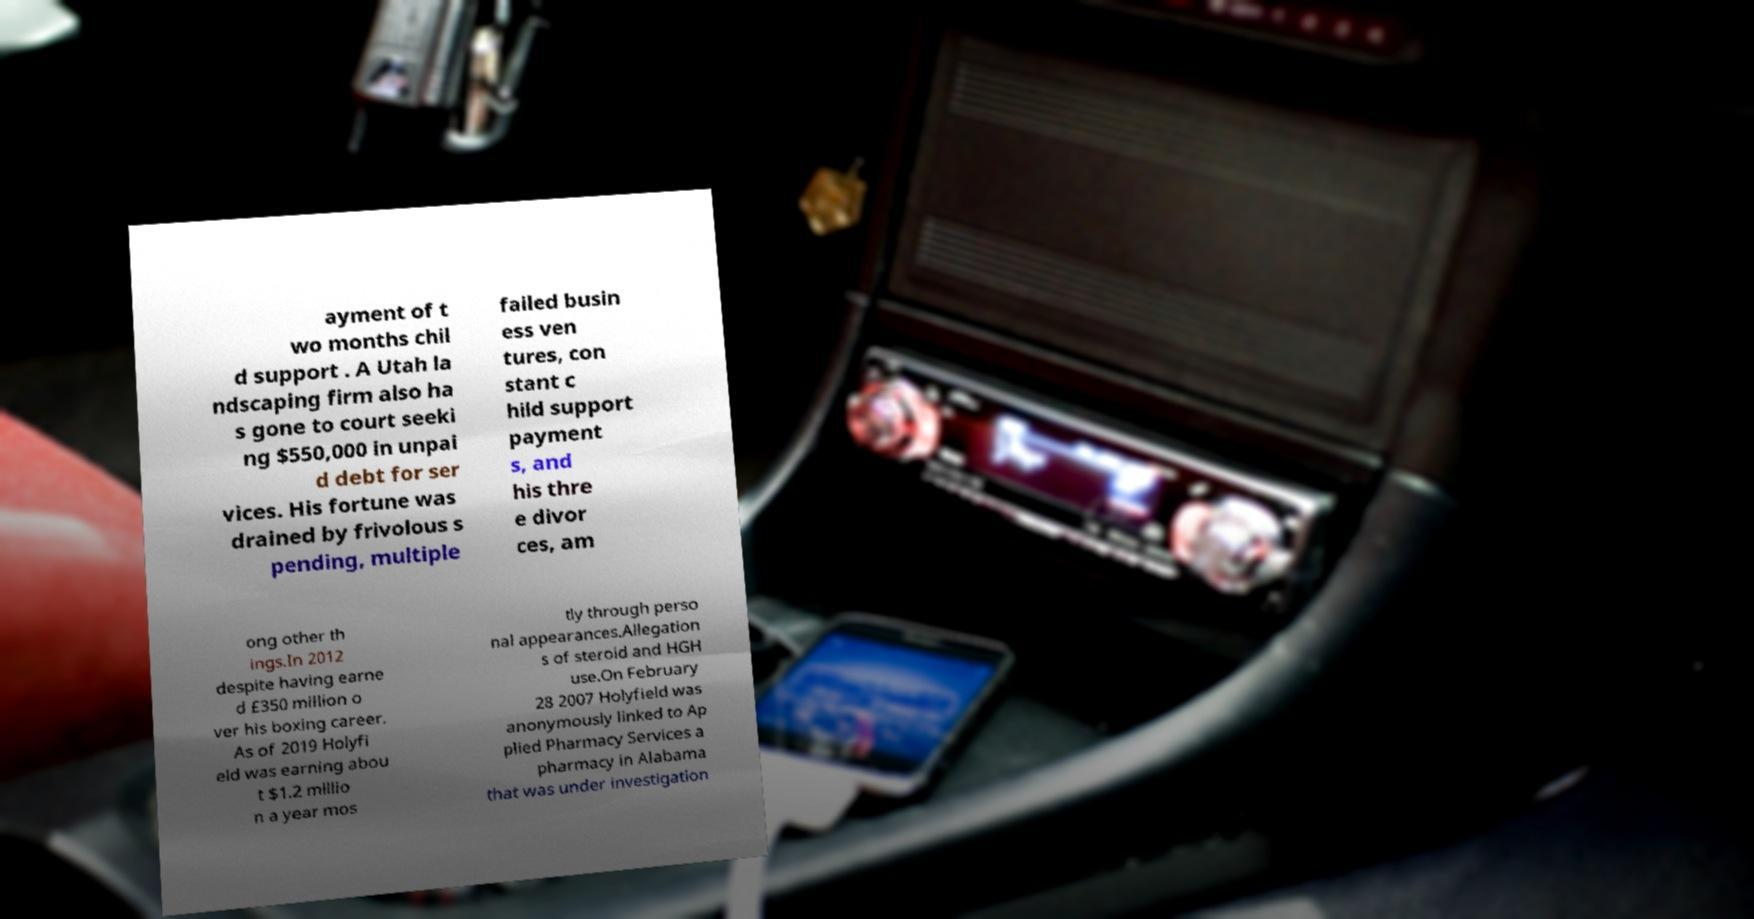Could you assist in decoding the text presented in this image and type it out clearly? ayment of t wo months chil d support . A Utah la ndscaping firm also ha s gone to court seeki ng $550,000 in unpai d debt for ser vices. His fortune was drained by frivolous s pending, multiple failed busin ess ven tures, con stant c hild support payment s, and his thre e divor ces, am ong other th ings.In 2012 despite having earne d £350 million o ver his boxing career. As of 2019 Holyfi eld was earning abou t $1.2 millio n a year mos tly through perso nal appearances.Allegation s of steroid and HGH use.On February 28 2007 Holyfield was anonymously linked to Ap plied Pharmacy Services a pharmacy in Alabama that was under investigation 